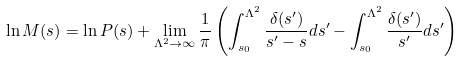<formula> <loc_0><loc_0><loc_500><loc_500>\ln M ( s ) = \ln P ( s ) + \lim _ { \Lambda ^ { 2 } \rightarrow \infty } \frac { 1 } { \pi } \left ( \int _ { s _ { 0 } } ^ { \Lambda ^ { 2 } } \frac { \delta ( s ^ { \prime } ) } { s ^ { \prime } - s } d s ^ { \prime } - \int _ { s _ { 0 } } ^ { \Lambda ^ { 2 } } \frac { \delta ( s ^ { \prime } ) } { s ^ { \prime } } d s ^ { \prime } \right )</formula> 